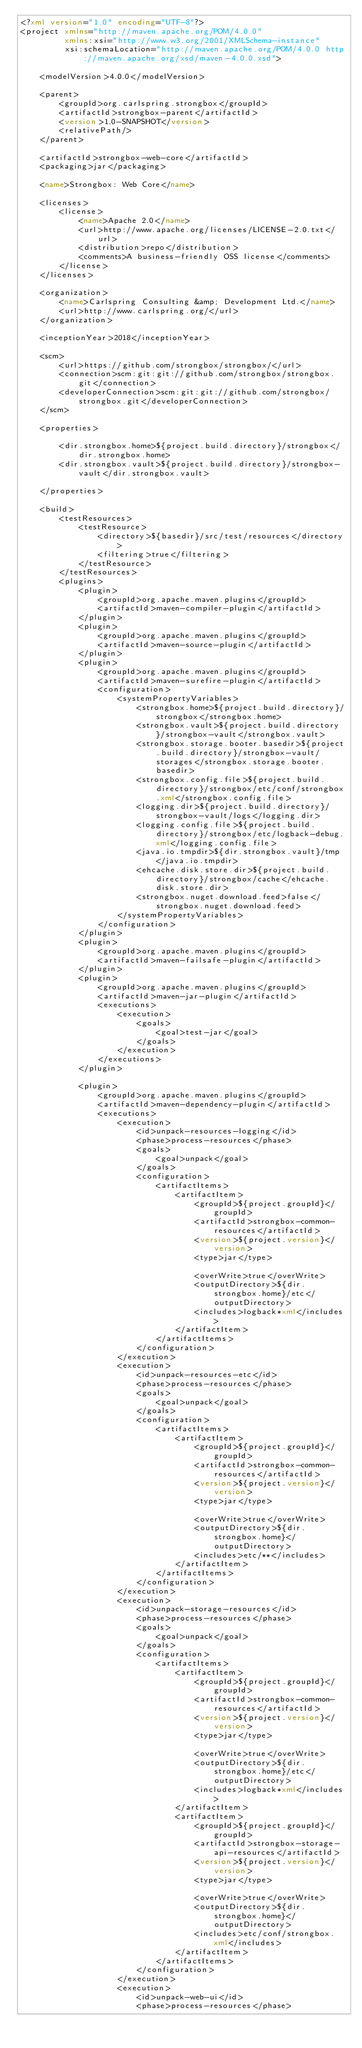Convert code to text. <code><loc_0><loc_0><loc_500><loc_500><_XML_><?xml version="1.0" encoding="UTF-8"?>
<project xmlns="http://maven.apache.org/POM/4.0.0"
         xmlns:xsi="http://www.w3.org/2001/XMLSchema-instance"
         xsi:schemaLocation="http://maven.apache.org/POM/4.0.0 http://maven.apache.org/xsd/maven-4.0.0.xsd">

    <modelVersion>4.0.0</modelVersion>

    <parent>
        <groupId>org.carlspring.strongbox</groupId>
        <artifactId>strongbox-parent</artifactId>
        <version>1.0-SNAPSHOT</version>
        <relativePath/>
    </parent>

    <artifactId>strongbox-web-core</artifactId>
    <packaging>jar</packaging>

    <name>Strongbox: Web Core</name>

    <licenses>
        <license>
            <name>Apache 2.0</name>
            <url>http://www.apache.org/licenses/LICENSE-2.0.txt</url>
            <distribution>repo</distribution>
            <comments>A business-friendly OSS license</comments>
        </license>
    </licenses>

    <organization>
        <name>Carlspring Consulting &amp; Development Ltd.</name>
        <url>http://www.carlspring.org/</url>
    </organization>

    <inceptionYear>2018</inceptionYear>

    <scm>
        <url>https://github.com/strongbox/strongbox/</url>
        <connection>scm:git:git://github.com/strongbox/strongbox.git</connection>
        <developerConnection>scm:git:git://github.com/strongbox/strongbox.git</developerConnection>
    </scm>

    <properties>

        <dir.strongbox.home>${project.build.directory}/strongbox</dir.strongbox.home>
        <dir.strongbox.vault>${project.build.directory}/strongbox-vault</dir.strongbox.vault>

    </properties>

    <build>
        <testResources>
            <testResource>
                <directory>${basedir}/src/test/resources</directory>
                <filtering>true</filtering>
            </testResource>
        </testResources>
        <plugins>
            <plugin>
                <groupId>org.apache.maven.plugins</groupId>
                <artifactId>maven-compiler-plugin</artifactId>
            </plugin>
            <plugin>
                <groupId>org.apache.maven.plugins</groupId>
                <artifactId>maven-source-plugin</artifactId>
            </plugin>
            <plugin>
                <groupId>org.apache.maven.plugins</groupId>
                <artifactId>maven-surefire-plugin</artifactId>
                <configuration>
                    <systemPropertyVariables>
                        <strongbox.home>${project.build.directory}/strongbox</strongbox.home>
                        <strongbox.vault>${project.build.directory}/strongbox-vault</strongbox.vault>
                        <strongbox.storage.booter.basedir>${project.build.directory}/strongbox-vault/storages</strongbox.storage.booter.basedir>
                        <strongbox.config.file>${project.build.directory}/strongbox/etc/conf/strongbox.xml</strongbox.config.file>
                        <logging.dir>${project.build.directory}/strongbox-vault/logs</logging.dir>
                        <logging.config.file>${project.build.directory}/strongbox/etc/logback-debug.xml</logging.config.file>
                        <java.io.tmpdir>${dir.strongbox.vault}/tmp</java.io.tmpdir>
                        <ehcache.disk.store.dir>${project.build.directory}/strongbox/cache</ehcache.disk.store.dir>
                        <strongbox.nuget.download.feed>false</strongbox.nuget.download.feed>
                    </systemPropertyVariables>
                </configuration>
            </plugin>
            <plugin>
                <groupId>org.apache.maven.plugins</groupId>
                <artifactId>maven-failsafe-plugin</artifactId>
            </plugin>
            <plugin>
                <groupId>org.apache.maven.plugins</groupId>
                <artifactId>maven-jar-plugin</artifactId>
                <executions>
                    <execution>
                        <goals>
                            <goal>test-jar</goal>
                        </goals>
                    </execution>
                </executions>
            </plugin>

            <plugin>
                <groupId>org.apache.maven.plugins</groupId>
                <artifactId>maven-dependency-plugin</artifactId>
                <executions>
                    <execution>
                        <id>unpack-resources-logging</id>
                        <phase>process-resources</phase>
                        <goals>
                            <goal>unpack</goal>
                        </goals>
                        <configuration>
                            <artifactItems>
                                <artifactItem>
                                    <groupId>${project.groupId}</groupId>
                                    <artifactId>strongbox-common-resources</artifactId>
                                    <version>${project.version}</version>
                                    <type>jar</type>

                                    <overWrite>true</overWrite>
                                    <outputDirectory>${dir.strongbox.home}/etc</outputDirectory>
                                    <includes>logback*xml</includes>
                                </artifactItem>
                            </artifactItems>
                        </configuration>
                    </execution>
                    <execution>
                        <id>unpack-resources-etc</id>
                        <phase>process-resources</phase>
                        <goals>
                            <goal>unpack</goal>
                        </goals>
                        <configuration>
                            <artifactItems>
                                <artifactItem>
                                    <groupId>${project.groupId}</groupId>
                                    <artifactId>strongbox-common-resources</artifactId>
                                    <version>${project.version}</version>
                                    <type>jar</type>

                                    <overWrite>true</overWrite>
                                    <outputDirectory>${dir.strongbox.home}</outputDirectory>
                                    <includes>etc/**</includes>
                                </artifactItem>
                            </artifactItems>
                        </configuration>
                    </execution>
                    <execution>
                        <id>unpack-storage-resources</id>
                        <phase>process-resources</phase>
                        <goals>
                            <goal>unpack</goal>
                        </goals>
                        <configuration>
                            <artifactItems>
                                <artifactItem>
                                    <groupId>${project.groupId}</groupId>
                                    <artifactId>strongbox-common-resources</artifactId>
                                    <version>${project.version}</version>
                                    <type>jar</type>

                                    <overWrite>true</overWrite>
                                    <outputDirectory>${dir.strongbox.home}/etc</outputDirectory>
                                    <includes>logback*xml</includes>
                                </artifactItem>
                                <artifactItem>
                                    <groupId>${project.groupId}</groupId>
                                    <artifactId>strongbox-storage-api-resources</artifactId>
                                    <version>${project.version}</version>
                                    <type>jar</type>

                                    <overWrite>true</overWrite>
                                    <outputDirectory>${dir.strongbox.home}</outputDirectory>
                                    <includes>etc/conf/strongbox.xml</includes>
                                </artifactItem>
                            </artifactItems>
                        </configuration>
                    </execution>
                    <execution>
                        <id>unpack-web-ui</id>
                        <phase>process-resources</phase></code> 